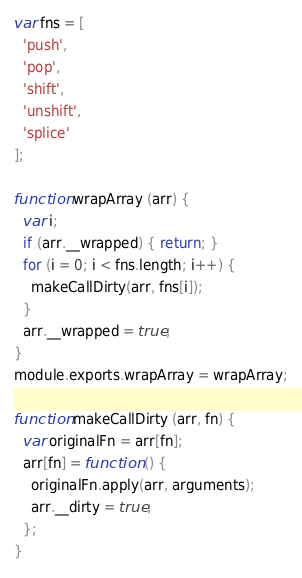Convert code to text. <code><loc_0><loc_0><loc_500><loc_500><_JavaScript_>var fns = [
  'push',
  'pop',
  'shift',
  'unshift',
  'splice'
];

function wrapArray (arr) {
  var i;
  if (arr.__wrapped) { return; }
  for (i = 0; i < fns.length; i++) {
    makeCallDirty(arr, fns[i]);
  }
  arr.__wrapped = true;
}
module.exports.wrapArray = wrapArray;

function makeCallDirty (arr, fn) {
  var originalFn = arr[fn];
  arr[fn] = function () {
    originalFn.apply(arr, arguments);
    arr.__dirty = true;
  };
}
</code> 